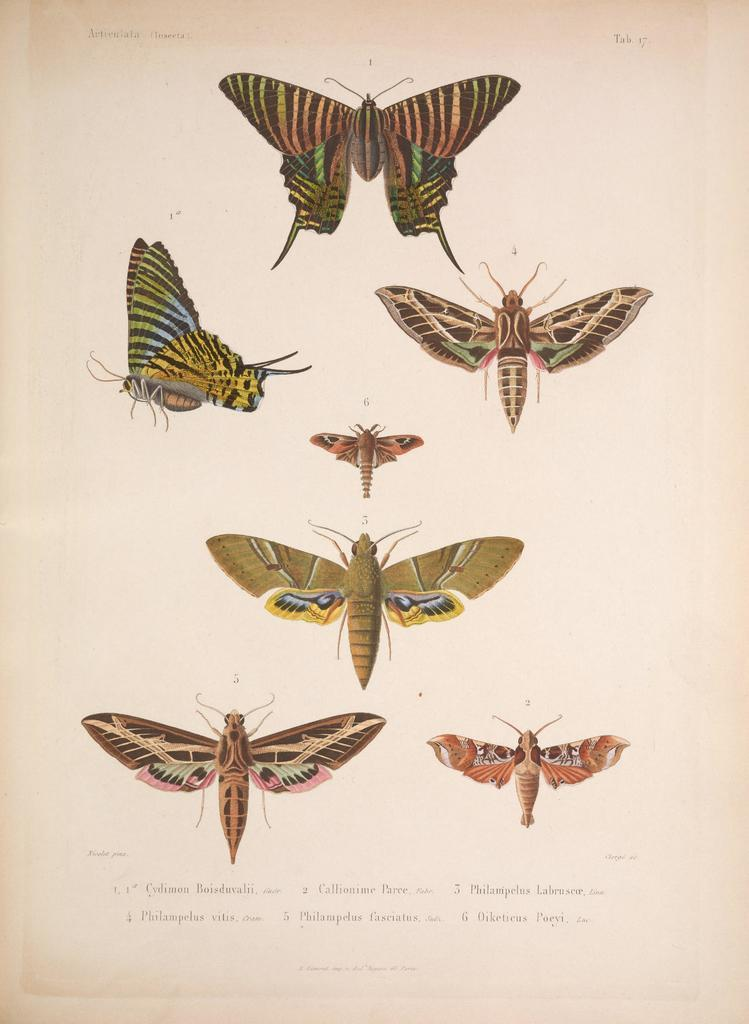What type of animals can be seen in the image? There are colorful butterflies in the image. What else is present in the image besides the butterflies? There is a paper with writing on it in the image. How many beds can be seen in the image? There are no beds present in the image. What type of rock is being used as a paperweight on the paper? There is no rock present in the image; the paper is not being held down by any object. 